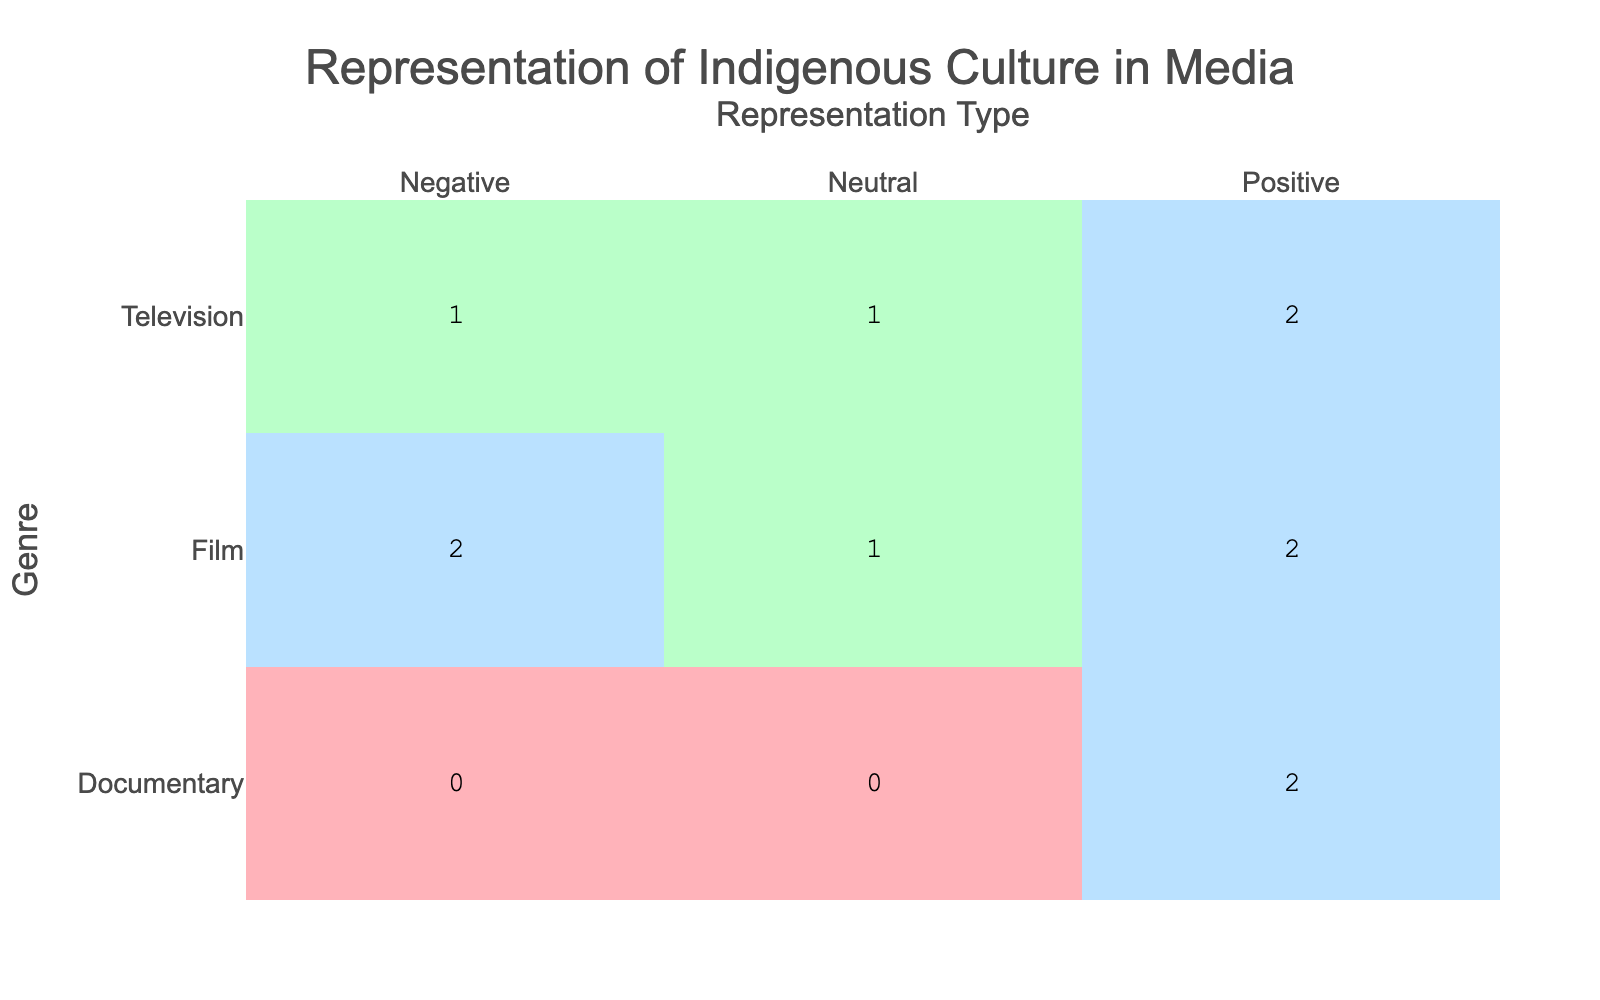What is the total number of positive representations in films? In the table, we look at the films listed and identify which have a "Positive" representation type. The films that fall under this category are "Smoke Signals" (2000), "The Money Pit" (2018), "Ronnie's World" (2021), and we find that there are 3 positive representations in total.
Answer: 3 Which genre has the highest number of negative representations? By examining the "Negative" representation type for each genre, we see that "Film" has 2 negative representations ("The Lone Ranger" and "Wind River") while "Television" has 1 ("The Money Pit"). Therefore, the genre with the most negative representations is "Film" with 2 occurrences.
Answer: Film Is there any documentary that represents Indigenous culture negatively? Checking the table, we see there are three entries for "Documentary," and all of them are marked as "Positive." This indicates that there are no documentaries with a negative representation of Indigenous culture.
Answer: No What is the difference in the number of positive representations between television and film? First, we count the positive representations in each genre. For "Television," we have "Into the West," "Dark Winds," and "The Red Road," totaling 3 positive representations. For "Film," the count is "Smoke Signals," "Ronnie's World," which totals 3 as well. The difference between television and film positive representations is zero.
Answer: 0 How many total representations in documentaries are there? The table shows that there are three documentaries listed: "In the Light of Reverence," "Awakening the Sleeping Giant," and their representation types are both marked as "Positive." Thus, the total number of representations in documentaries is 3.
Answer: 3 What percentage of films have a negative representation? In total, we see there are 7 films in the table, with 2 of them being negative representations ("The Lone Ranger" and "Wind River"). To find the percentage, we calculate (2 negatives / 7 total films) * 100 = approximately 28.57%.
Answer: 28.57% 